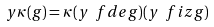<formula> <loc_0><loc_0><loc_500><loc_500>y \kappa ( g ) = \kappa ( y \ f d e g ) ( y \ f i z g )</formula> 